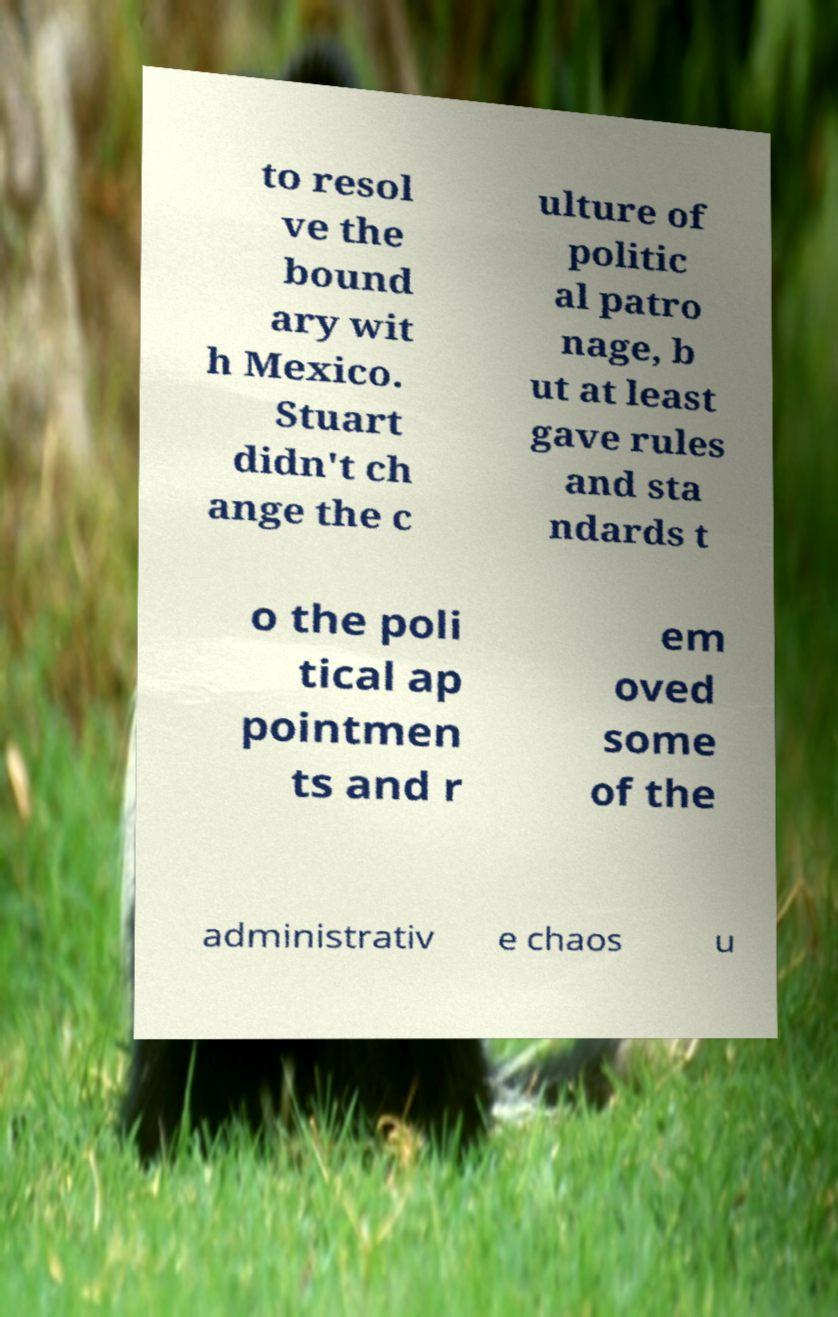Could you assist in decoding the text presented in this image and type it out clearly? to resol ve the bound ary wit h Mexico. Stuart didn't ch ange the c ulture of politic al patro nage, b ut at least gave rules and sta ndards t o the poli tical ap pointmen ts and r em oved some of the administrativ e chaos u 